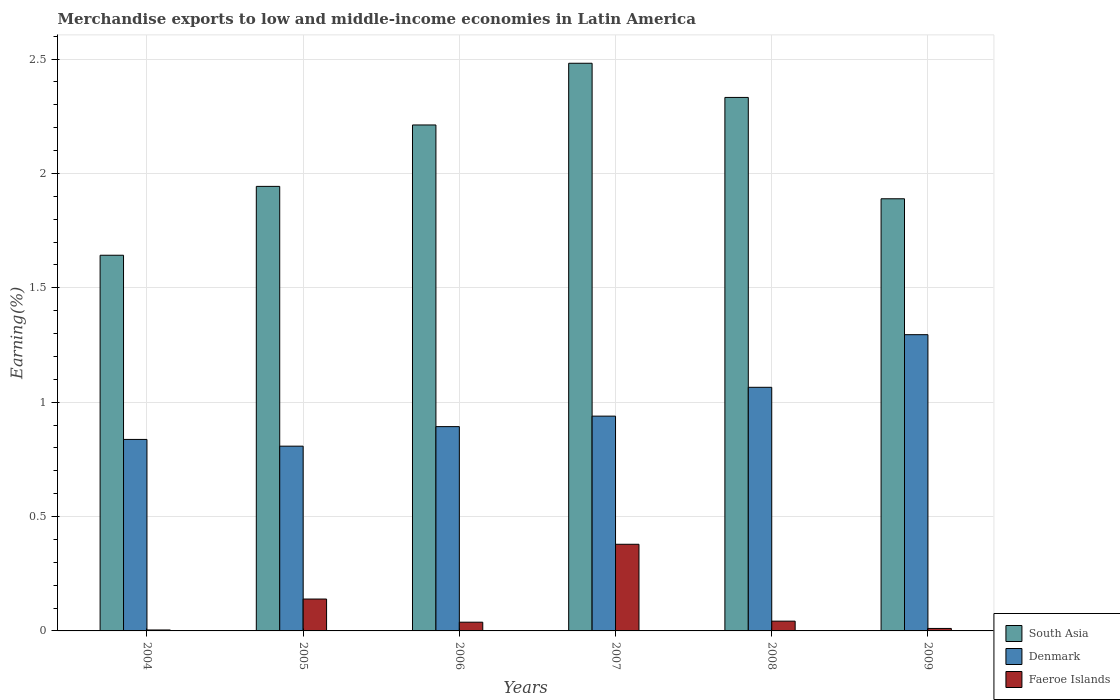How many different coloured bars are there?
Offer a terse response. 3. Are the number of bars on each tick of the X-axis equal?
Give a very brief answer. Yes. What is the percentage of amount earned from merchandise exports in South Asia in 2007?
Your answer should be compact. 2.48. Across all years, what is the maximum percentage of amount earned from merchandise exports in Faeroe Islands?
Provide a short and direct response. 0.38. Across all years, what is the minimum percentage of amount earned from merchandise exports in Faeroe Islands?
Keep it short and to the point. 0. In which year was the percentage of amount earned from merchandise exports in South Asia minimum?
Ensure brevity in your answer.  2004. What is the total percentage of amount earned from merchandise exports in Denmark in the graph?
Your response must be concise. 5.84. What is the difference between the percentage of amount earned from merchandise exports in South Asia in 2004 and that in 2005?
Your response must be concise. -0.3. What is the difference between the percentage of amount earned from merchandise exports in Faeroe Islands in 2005 and the percentage of amount earned from merchandise exports in Denmark in 2004?
Give a very brief answer. -0.7. What is the average percentage of amount earned from merchandise exports in South Asia per year?
Your answer should be compact. 2.08. In the year 2008, what is the difference between the percentage of amount earned from merchandise exports in Faeroe Islands and percentage of amount earned from merchandise exports in South Asia?
Your response must be concise. -2.29. In how many years, is the percentage of amount earned from merchandise exports in Faeroe Islands greater than 2.5 %?
Your answer should be very brief. 0. What is the ratio of the percentage of amount earned from merchandise exports in South Asia in 2004 to that in 2009?
Ensure brevity in your answer.  0.87. Is the difference between the percentage of amount earned from merchandise exports in Faeroe Islands in 2005 and 2008 greater than the difference between the percentage of amount earned from merchandise exports in South Asia in 2005 and 2008?
Offer a very short reply. Yes. What is the difference between the highest and the second highest percentage of amount earned from merchandise exports in South Asia?
Provide a short and direct response. 0.15. What is the difference between the highest and the lowest percentage of amount earned from merchandise exports in Faeroe Islands?
Your answer should be very brief. 0.37. What does the 3rd bar from the left in 2004 represents?
Your answer should be compact. Faeroe Islands. What does the 2nd bar from the right in 2007 represents?
Give a very brief answer. Denmark. How many bars are there?
Offer a terse response. 18. How many years are there in the graph?
Offer a terse response. 6. What is the difference between two consecutive major ticks on the Y-axis?
Offer a very short reply. 0.5. Where does the legend appear in the graph?
Ensure brevity in your answer.  Bottom right. What is the title of the graph?
Your response must be concise. Merchandise exports to low and middle-income economies in Latin America. What is the label or title of the X-axis?
Provide a succinct answer. Years. What is the label or title of the Y-axis?
Give a very brief answer. Earning(%). What is the Earning(%) of South Asia in 2004?
Give a very brief answer. 1.64. What is the Earning(%) in Denmark in 2004?
Provide a succinct answer. 0.84. What is the Earning(%) in Faeroe Islands in 2004?
Your response must be concise. 0. What is the Earning(%) in South Asia in 2005?
Offer a terse response. 1.94. What is the Earning(%) of Denmark in 2005?
Your answer should be very brief. 0.81. What is the Earning(%) in Faeroe Islands in 2005?
Make the answer very short. 0.14. What is the Earning(%) of South Asia in 2006?
Keep it short and to the point. 2.21. What is the Earning(%) in Denmark in 2006?
Offer a terse response. 0.89. What is the Earning(%) of Faeroe Islands in 2006?
Make the answer very short. 0.04. What is the Earning(%) in South Asia in 2007?
Provide a succinct answer. 2.48. What is the Earning(%) of Denmark in 2007?
Your answer should be very brief. 0.94. What is the Earning(%) in Faeroe Islands in 2007?
Ensure brevity in your answer.  0.38. What is the Earning(%) in South Asia in 2008?
Your answer should be very brief. 2.33. What is the Earning(%) in Denmark in 2008?
Give a very brief answer. 1.07. What is the Earning(%) of Faeroe Islands in 2008?
Keep it short and to the point. 0.04. What is the Earning(%) of South Asia in 2009?
Keep it short and to the point. 1.89. What is the Earning(%) of Denmark in 2009?
Your answer should be very brief. 1.3. What is the Earning(%) of Faeroe Islands in 2009?
Give a very brief answer. 0.01. Across all years, what is the maximum Earning(%) in South Asia?
Give a very brief answer. 2.48. Across all years, what is the maximum Earning(%) of Denmark?
Make the answer very short. 1.3. Across all years, what is the maximum Earning(%) in Faeroe Islands?
Make the answer very short. 0.38. Across all years, what is the minimum Earning(%) of South Asia?
Provide a short and direct response. 1.64. Across all years, what is the minimum Earning(%) in Denmark?
Your answer should be very brief. 0.81. Across all years, what is the minimum Earning(%) in Faeroe Islands?
Keep it short and to the point. 0. What is the total Earning(%) in South Asia in the graph?
Offer a very short reply. 12.5. What is the total Earning(%) in Denmark in the graph?
Provide a succinct answer. 5.84. What is the total Earning(%) in Faeroe Islands in the graph?
Provide a short and direct response. 0.61. What is the difference between the Earning(%) of South Asia in 2004 and that in 2005?
Give a very brief answer. -0.3. What is the difference between the Earning(%) in Denmark in 2004 and that in 2005?
Make the answer very short. 0.03. What is the difference between the Earning(%) in Faeroe Islands in 2004 and that in 2005?
Ensure brevity in your answer.  -0.14. What is the difference between the Earning(%) of South Asia in 2004 and that in 2006?
Your answer should be very brief. -0.57. What is the difference between the Earning(%) in Denmark in 2004 and that in 2006?
Provide a succinct answer. -0.06. What is the difference between the Earning(%) of Faeroe Islands in 2004 and that in 2006?
Keep it short and to the point. -0.03. What is the difference between the Earning(%) in South Asia in 2004 and that in 2007?
Provide a succinct answer. -0.84. What is the difference between the Earning(%) of Denmark in 2004 and that in 2007?
Offer a very short reply. -0.1. What is the difference between the Earning(%) of Faeroe Islands in 2004 and that in 2007?
Offer a terse response. -0.37. What is the difference between the Earning(%) of South Asia in 2004 and that in 2008?
Your answer should be very brief. -0.69. What is the difference between the Earning(%) in Denmark in 2004 and that in 2008?
Ensure brevity in your answer.  -0.23. What is the difference between the Earning(%) of Faeroe Islands in 2004 and that in 2008?
Offer a very short reply. -0.04. What is the difference between the Earning(%) in South Asia in 2004 and that in 2009?
Ensure brevity in your answer.  -0.25. What is the difference between the Earning(%) in Denmark in 2004 and that in 2009?
Offer a very short reply. -0.46. What is the difference between the Earning(%) in Faeroe Islands in 2004 and that in 2009?
Your answer should be compact. -0.01. What is the difference between the Earning(%) of South Asia in 2005 and that in 2006?
Offer a terse response. -0.27. What is the difference between the Earning(%) of Denmark in 2005 and that in 2006?
Your answer should be compact. -0.09. What is the difference between the Earning(%) in Faeroe Islands in 2005 and that in 2006?
Your answer should be very brief. 0.1. What is the difference between the Earning(%) in South Asia in 2005 and that in 2007?
Provide a short and direct response. -0.54. What is the difference between the Earning(%) in Denmark in 2005 and that in 2007?
Your response must be concise. -0.13. What is the difference between the Earning(%) of Faeroe Islands in 2005 and that in 2007?
Your answer should be compact. -0.24. What is the difference between the Earning(%) of South Asia in 2005 and that in 2008?
Offer a terse response. -0.39. What is the difference between the Earning(%) of Denmark in 2005 and that in 2008?
Make the answer very short. -0.26. What is the difference between the Earning(%) of Faeroe Islands in 2005 and that in 2008?
Your answer should be very brief. 0.1. What is the difference between the Earning(%) of South Asia in 2005 and that in 2009?
Ensure brevity in your answer.  0.05. What is the difference between the Earning(%) of Denmark in 2005 and that in 2009?
Provide a succinct answer. -0.49. What is the difference between the Earning(%) of Faeroe Islands in 2005 and that in 2009?
Offer a very short reply. 0.13. What is the difference between the Earning(%) of South Asia in 2006 and that in 2007?
Offer a terse response. -0.27. What is the difference between the Earning(%) of Denmark in 2006 and that in 2007?
Offer a terse response. -0.05. What is the difference between the Earning(%) of Faeroe Islands in 2006 and that in 2007?
Offer a terse response. -0.34. What is the difference between the Earning(%) in South Asia in 2006 and that in 2008?
Offer a very short reply. -0.12. What is the difference between the Earning(%) of Denmark in 2006 and that in 2008?
Your answer should be compact. -0.17. What is the difference between the Earning(%) in Faeroe Islands in 2006 and that in 2008?
Make the answer very short. -0. What is the difference between the Earning(%) of South Asia in 2006 and that in 2009?
Give a very brief answer. 0.32. What is the difference between the Earning(%) of Denmark in 2006 and that in 2009?
Your answer should be very brief. -0.4. What is the difference between the Earning(%) of Faeroe Islands in 2006 and that in 2009?
Provide a short and direct response. 0.03. What is the difference between the Earning(%) in South Asia in 2007 and that in 2008?
Offer a terse response. 0.15. What is the difference between the Earning(%) in Denmark in 2007 and that in 2008?
Provide a succinct answer. -0.13. What is the difference between the Earning(%) in Faeroe Islands in 2007 and that in 2008?
Give a very brief answer. 0.34. What is the difference between the Earning(%) of South Asia in 2007 and that in 2009?
Offer a terse response. 0.59. What is the difference between the Earning(%) in Denmark in 2007 and that in 2009?
Keep it short and to the point. -0.36. What is the difference between the Earning(%) in Faeroe Islands in 2007 and that in 2009?
Provide a short and direct response. 0.37. What is the difference between the Earning(%) of South Asia in 2008 and that in 2009?
Give a very brief answer. 0.44. What is the difference between the Earning(%) of Denmark in 2008 and that in 2009?
Ensure brevity in your answer.  -0.23. What is the difference between the Earning(%) of Faeroe Islands in 2008 and that in 2009?
Your response must be concise. 0.03. What is the difference between the Earning(%) of South Asia in 2004 and the Earning(%) of Denmark in 2005?
Your response must be concise. 0.83. What is the difference between the Earning(%) in South Asia in 2004 and the Earning(%) in Faeroe Islands in 2005?
Ensure brevity in your answer.  1.5. What is the difference between the Earning(%) in Denmark in 2004 and the Earning(%) in Faeroe Islands in 2005?
Provide a short and direct response. 0.7. What is the difference between the Earning(%) in South Asia in 2004 and the Earning(%) in Denmark in 2006?
Give a very brief answer. 0.75. What is the difference between the Earning(%) in South Asia in 2004 and the Earning(%) in Faeroe Islands in 2006?
Your answer should be very brief. 1.6. What is the difference between the Earning(%) of Denmark in 2004 and the Earning(%) of Faeroe Islands in 2006?
Ensure brevity in your answer.  0.8. What is the difference between the Earning(%) of South Asia in 2004 and the Earning(%) of Denmark in 2007?
Provide a short and direct response. 0.7. What is the difference between the Earning(%) of South Asia in 2004 and the Earning(%) of Faeroe Islands in 2007?
Provide a succinct answer. 1.26. What is the difference between the Earning(%) in Denmark in 2004 and the Earning(%) in Faeroe Islands in 2007?
Provide a succinct answer. 0.46. What is the difference between the Earning(%) of South Asia in 2004 and the Earning(%) of Denmark in 2008?
Offer a terse response. 0.58. What is the difference between the Earning(%) of South Asia in 2004 and the Earning(%) of Faeroe Islands in 2008?
Provide a succinct answer. 1.6. What is the difference between the Earning(%) in Denmark in 2004 and the Earning(%) in Faeroe Islands in 2008?
Offer a very short reply. 0.79. What is the difference between the Earning(%) of South Asia in 2004 and the Earning(%) of Denmark in 2009?
Offer a terse response. 0.35. What is the difference between the Earning(%) of South Asia in 2004 and the Earning(%) of Faeroe Islands in 2009?
Make the answer very short. 1.63. What is the difference between the Earning(%) in Denmark in 2004 and the Earning(%) in Faeroe Islands in 2009?
Ensure brevity in your answer.  0.83. What is the difference between the Earning(%) of South Asia in 2005 and the Earning(%) of Denmark in 2006?
Ensure brevity in your answer.  1.05. What is the difference between the Earning(%) in South Asia in 2005 and the Earning(%) in Faeroe Islands in 2006?
Offer a terse response. 1.91. What is the difference between the Earning(%) of Denmark in 2005 and the Earning(%) of Faeroe Islands in 2006?
Ensure brevity in your answer.  0.77. What is the difference between the Earning(%) in South Asia in 2005 and the Earning(%) in Faeroe Islands in 2007?
Keep it short and to the point. 1.56. What is the difference between the Earning(%) in Denmark in 2005 and the Earning(%) in Faeroe Islands in 2007?
Make the answer very short. 0.43. What is the difference between the Earning(%) in South Asia in 2005 and the Earning(%) in Denmark in 2008?
Offer a terse response. 0.88. What is the difference between the Earning(%) in South Asia in 2005 and the Earning(%) in Faeroe Islands in 2008?
Provide a succinct answer. 1.9. What is the difference between the Earning(%) in Denmark in 2005 and the Earning(%) in Faeroe Islands in 2008?
Your answer should be compact. 0.77. What is the difference between the Earning(%) of South Asia in 2005 and the Earning(%) of Denmark in 2009?
Make the answer very short. 0.65. What is the difference between the Earning(%) of South Asia in 2005 and the Earning(%) of Faeroe Islands in 2009?
Offer a terse response. 1.93. What is the difference between the Earning(%) in Denmark in 2005 and the Earning(%) in Faeroe Islands in 2009?
Give a very brief answer. 0.8. What is the difference between the Earning(%) in South Asia in 2006 and the Earning(%) in Denmark in 2007?
Your answer should be very brief. 1.27. What is the difference between the Earning(%) in South Asia in 2006 and the Earning(%) in Faeroe Islands in 2007?
Your answer should be very brief. 1.83. What is the difference between the Earning(%) of Denmark in 2006 and the Earning(%) of Faeroe Islands in 2007?
Your answer should be compact. 0.51. What is the difference between the Earning(%) of South Asia in 2006 and the Earning(%) of Denmark in 2008?
Offer a very short reply. 1.15. What is the difference between the Earning(%) of South Asia in 2006 and the Earning(%) of Faeroe Islands in 2008?
Keep it short and to the point. 2.17. What is the difference between the Earning(%) in Denmark in 2006 and the Earning(%) in Faeroe Islands in 2008?
Make the answer very short. 0.85. What is the difference between the Earning(%) in South Asia in 2006 and the Earning(%) in Denmark in 2009?
Provide a succinct answer. 0.92. What is the difference between the Earning(%) in South Asia in 2006 and the Earning(%) in Faeroe Islands in 2009?
Ensure brevity in your answer.  2.2. What is the difference between the Earning(%) in Denmark in 2006 and the Earning(%) in Faeroe Islands in 2009?
Your answer should be very brief. 0.88. What is the difference between the Earning(%) of South Asia in 2007 and the Earning(%) of Denmark in 2008?
Provide a short and direct response. 1.42. What is the difference between the Earning(%) in South Asia in 2007 and the Earning(%) in Faeroe Islands in 2008?
Give a very brief answer. 2.44. What is the difference between the Earning(%) of Denmark in 2007 and the Earning(%) of Faeroe Islands in 2008?
Offer a very short reply. 0.9. What is the difference between the Earning(%) in South Asia in 2007 and the Earning(%) in Denmark in 2009?
Provide a succinct answer. 1.19. What is the difference between the Earning(%) of South Asia in 2007 and the Earning(%) of Faeroe Islands in 2009?
Provide a short and direct response. 2.47. What is the difference between the Earning(%) in Denmark in 2007 and the Earning(%) in Faeroe Islands in 2009?
Offer a terse response. 0.93. What is the difference between the Earning(%) in South Asia in 2008 and the Earning(%) in Denmark in 2009?
Ensure brevity in your answer.  1.04. What is the difference between the Earning(%) of South Asia in 2008 and the Earning(%) of Faeroe Islands in 2009?
Provide a short and direct response. 2.32. What is the difference between the Earning(%) in Denmark in 2008 and the Earning(%) in Faeroe Islands in 2009?
Provide a succinct answer. 1.05. What is the average Earning(%) of South Asia per year?
Provide a succinct answer. 2.08. What is the average Earning(%) of Denmark per year?
Offer a very short reply. 0.97. What is the average Earning(%) of Faeroe Islands per year?
Give a very brief answer. 0.1. In the year 2004, what is the difference between the Earning(%) in South Asia and Earning(%) in Denmark?
Make the answer very short. 0.81. In the year 2004, what is the difference between the Earning(%) of South Asia and Earning(%) of Faeroe Islands?
Offer a terse response. 1.64. In the year 2004, what is the difference between the Earning(%) of Denmark and Earning(%) of Faeroe Islands?
Your response must be concise. 0.83. In the year 2005, what is the difference between the Earning(%) in South Asia and Earning(%) in Denmark?
Offer a terse response. 1.14. In the year 2005, what is the difference between the Earning(%) in South Asia and Earning(%) in Faeroe Islands?
Make the answer very short. 1.8. In the year 2005, what is the difference between the Earning(%) in Denmark and Earning(%) in Faeroe Islands?
Give a very brief answer. 0.67. In the year 2006, what is the difference between the Earning(%) in South Asia and Earning(%) in Denmark?
Ensure brevity in your answer.  1.32. In the year 2006, what is the difference between the Earning(%) of South Asia and Earning(%) of Faeroe Islands?
Provide a short and direct response. 2.17. In the year 2006, what is the difference between the Earning(%) of Denmark and Earning(%) of Faeroe Islands?
Make the answer very short. 0.86. In the year 2007, what is the difference between the Earning(%) of South Asia and Earning(%) of Denmark?
Keep it short and to the point. 1.54. In the year 2007, what is the difference between the Earning(%) in South Asia and Earning(%) in Faeroe Islands?
Offer a terse response. 2.1. In the year 2007, what is the difference between the Earning(%) in Denmark and Earning(%) in Faeroe Islands?
Keep it short and to the point. 0.56. In the year 2008, what is the difference between the Earning(%) of South Asia and Earning(%) of Denmark?
Your answer should be compact. 1.27. In the year 2008, what is the difference between the Earning(%) of South Asia and Earning(%) of Faeroe Islands?
Make the answer very short. 2.29. In the year 2008, what is the difference between the Earning(%) of Denmark and Earning(%) of Faeroe Islands?
Your response must be concise. 1.02. In the year 2009, what is the difference between the Earning(%) of South Asia and Earning(%) of Denmark?
Provide a short and direct response. 0.59. In the year 2009, what is the difference between the Earning(%) of South Asia and Earning(%) of Faeroe Islands?
Make the answer very short. 1.88. In the year 2009, what is the difference between the Earning(%) of Denmark and Earning(%) of Faeroe Islands?
Your response must be concise. 1.28. What is the ratio of the Earning(%) in South Asia in 2004 to that in 2005?
Make the answer very short. 0.85. What is the ratio of the Earning(%) of Denmark in 2004 to that in 2005?
Your answer should be very brief. 1.04. What is the ratio of the Earning(%) in Faeroe Islands in 2004 to that in 2005?
Provide a succinct answer. 0.03. What is the ratio of the Earning(%) of South Asia in 2004 to that in 2006?
Offer a very short reply. 0.74. What is the ratio of the Earning(%) in Denmark in 2004 to that in 2006?
Offer a terse response. 0.94. What is the ratio of the Earning(%) in Faeroe Islands in 2004 to that in 2006?
Provide a short and direct response. 0.11. What is the ratio of the Earning(%) of South Asia in 2004 to that in 2007?
Provide a succinct answer. 0.66. What is the ratio of the Earning(%) of Denmark in 2004 to that in 2007?
Offer a terse response. 0.89. What is the ratio of the Earning(%) of Faeroe Islands in 2004 to that in 2007?
Keep it short and to the point. 0.01. What is the ratio of the Earning(%) of South Asia in 2004 to that in 2008?
Your answer should be very brief. 0.7. What is the ratio of the Earning(%) of Denmark in 2004 to that in 2008?
Offer a very short reply. 0.79. What is the ratio of the Earning(%) in Faeroe Islands in 2004 to that in 2008?
Provide a succinct answer. 0.1. What is the ratio of the Earning(%) of South Asia in 2004 to that in 2009?
Keep it short and to the point. 0.87. What is the ratio of the Earning(%) in Denmark in 2004 to that in 2009?
Your answer should be compact. 0.65. What is the ratio of the Earning(%) of Faeroe Islands in 2004 to that in 2009?
Ensure brevity in your answer.  0.38. What is the ratio of the Earning(%) of South Asia in 2005 to that in 2006?
Your response must be concise. 0.88. What is the ratio of the Earning(%) in Denmark in 2005 to that in 2006?
Your answer should be very brief. 0.9. What is the ratio of the Earning(%) in Faeroe Islands in 2005 to that in 2006?
Your answer should be compact. 3.65. What is the ratio of the Earning(%) in South Asia in 2005 to that in 2007?
Make the answer very short. 0.78. What is the ratio of the Earning(%) of Denmark in 2005 to that in 2007?
Keep it short and to the point. 0.86. What is the ratio of the Earning(%) in Faeroe Islands in 2005 to that in 2007?
Ensure brevity in your answer.  0.37. What is the ratio of the Earning(%) in Denmark in 2005 to that in 2008?
Give a very brief answer. 0.76. What is the ratio of the Earning(%) of Faeroe Islands in 2005 to that in 2008?
Provide a succinct answer. 3.26. What is the ratio of the Earning(%) in South Asia in 2005 to that in 2009?
Your answer should be very brief. 1.03. What is the ratio of the Earning(%) of Denmark in 2005 to that in 2009?
Offer a terse response. 0.62. What is the ratio of the Earning(%) in Faeroe Islands in 2005 to that in 2009?
Ensure brevity in your answer.  12.86. What is the ratio of the Earning(%) of South Asia in 2006 to that in 2007?
Your answer should be very brief. 0.89. What is the ratio of the Earning(%) of Denmark in 2006 to that in 2007?
Ensure brevity in your answer.  0.95. What is the ratio of the Earning(%) of Faeroe Islands in 2006 to that in 2007?
Provide a short and direct response. 0.1. What is the ratio of the Earning(%) in South Asia in 2006 to that in 2008?
Provide a succinct answer. 0.95. What is the ratio of the Earning(%) of Denmark in 2006 to that in 2008?
Your answer should be very brief. 0.84. What is the ratio of the Earning(%) of Faeroe Islands in 2006 to that in 2008?
Offer a very short reply. 0.89. What is the ratio of the Earning(%) in South Asia in 2006 to that in 2009?
Ensure brevity in your answer.  1.17. What is the ratio of the Earning(%) in Denmark in 2006 to that in 2009?
Ensure brevity in your answer.  0.69. What is the ratio of the Earning(%) of Faeroe Islands in 2006 to that in 2009?
Provide a succinct answer. 3.52. What is the ratio of the Earning(%) in South Asia in 2007 to that in 2008?
Provide a succinct answer. 1.06. What is the ratio of the Earning(%) of Denmark in 2007 to that in 2008?
Offer a very short reply. 0.88. What is the ratio of the Earning(%) of Faeroe Islands in 2007 to that in 2008?
Make the answer very short. 8.86. What is the ratio of the Earning(%) in South Asia in 2007 to that in 2009?
Offer a terse response. 1.31. What is the ratio of the Earning(%) in Denmark in 2007 to that in 2009?
Provide a short and direct response. 0.73. What is the ratio of the Earning(%) of Faeroe Islands in 2007 to that in 2009?
Ensure brevity in your answer.  34.95. What is the ratio of the Earning(%) of South Asia in 2008 to that in 2009?
Keep it short and to the point. 1.23. What is the ratio of the Earning(%) in Denmark in 2008 to that in 2009?
Provide a succinct answer. 0.82. What is the ratio of the Earning(%) of Faeroe Islands in 2008 to that in 2009?
Your answer should be very brief. 3.94. What is the difference between the highest and the second highest Earning(%) in South Asia?
Your answer should be very brief. 0.15. What is the difference between the highest and the second highest Earning(%) of Denmark?
Ensure brevity in your answer.  0.23. What is the difference between the highest and the second highest Earning(%) in Faeroe Islands?
Your answer should be compact. 0.24. What is the difference between the highest and the lowest Earning(%) in South Asia?
Offer a very short reply. 0.84. What is the difference between the highest and the lowest Earning(%) in Denmark?
Offer a very short reply. 0.49. What is the difference between the highest and the lowest Earning(%) of Faeroe Islands?
Your answer should be compact. 0.37. 